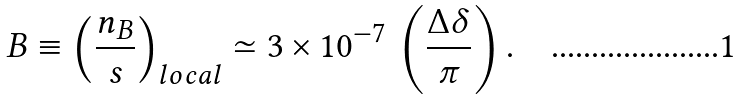Convert formula to latex. <formula><loc_0><loc_0><loc_500><loc_500>B \equiv \left ( \frac { n _ { B } } { s } \right ) _ { l o c a l } \simeq 3 \times 1 0 ^ { - 7 } \, \left ( \frac { \Delta \delta } { \pi } \right ) .</formula> 